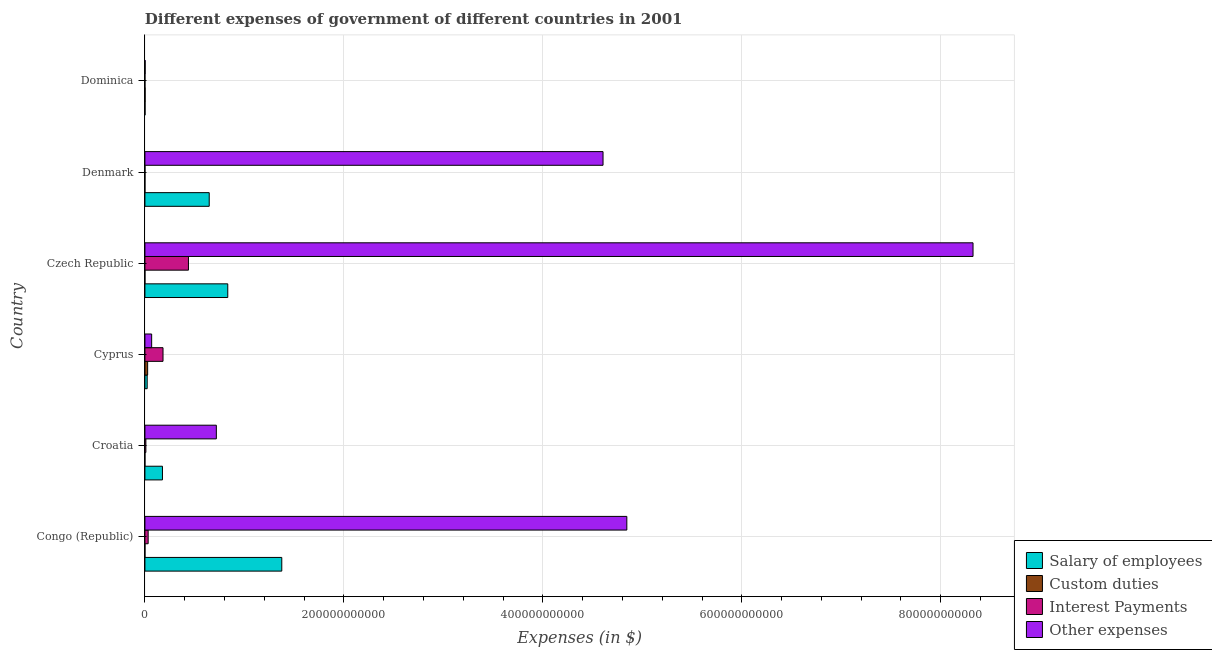How many different coloured bars are there?
Provide a short and direct response. 4. Are the number of bars per tick equal to the number of legend labels?
Your answer should be compact. No. How many bars are there on the 2nd tick from the top?
Ensure brevity in your answer.  4. How many bars are there on the 5th tick from the bottom?
Ensure brevity in your answer.  4. What is the label of the 2nd group of bars from the top?
Ensure brevity in your answer.  Denmark. In how many cases, is the number of bars for a given country not equal to the number of legend labels?
Your answer should be very brief. 1. What is the amount spent on custom duties in Dominica?
Provide a succinct answer. 2.00e+08. Across all countries, what is the maximum amount spent on salary of employees?
Your answer should be compact. 1.38e+11. Across all countries, what is the minimum amount spent on salary of employees?
Make the answer very short. 1.24e+08. In which country was the amount spent on salary of employees maximum?
Offer a terse response. Congo (Republic). What is the total amount spent on custom duties in the graph?
Offer a terse response. 2.97e+09. What is the difference between the amount spent on other expenses in Cyprus and that in Denmark?
Your answer should be very brief. -4.54e+11. What is the difference between the amount spent on salary of employees in Cyprus and the amount spent on other expenses in Congo (Republic)?
Make the answer very short. -4.82e+11. What is the average amount spent on custom duties per country?
Give a very brief answer. 4.94e+08. What is the difference between the amount spent on salary of employees and amount spent on custom duties in Cyprus?
Keep it short and to the point. -4.53e+08. What is the ratio of the amount spent on salary of employees in Cyprus to that in Denmark?
Make the answer very short. 0.04. Is the amount spent on interest payments in Congo (Republic) less than that in Czech Republic?
Give a very brief answer. Yes. Is the difference between the amount spent on interest payments in Denmark and Dominica greater than the difference between the amount spent on custom duties in Denmark and Dominica?
Provide a short and direct response. Yes. What is the difference between the highest and the second highest amount spent on salary of employees?
Offer a terse response. 5.43e+1. What is the difference between the highest and the lowest amount spent on other expenses?
Provide a short and direct response. 8.32e+11. Are all the bars in the graph horizontal?
Ensure brevity in your answer.  Yes. What is the difference between two consecutive major ticks on the X-axis?
Offer a terse response. 2.00e+11. Are the values on the major ticks of X-axis written in scientific E-notation?
Provide a succinct answer. No. Where does the legend appear in the graph?
Keep it short and to the point. Bottom right. How many legend labels are there?
Your response must be concise. 4. How are the legend labels stacked?
Give a very brief answer. Vertical. What is the title of the graph?
Your answer should be very brief. Different expenses of government of different countries in 2001. Does "Payroll services" appear as one of the legend labels in the graph?
Keep it short and to the point. No. What is the label or title of the X-axis?
Provide a succinct answer. Expenses (in $). What is the Expenses (in $) of Salary of employees in Congo (Republic)?
Your answer should be very brief. 1.38e+11. What is the Expenses (in $) in Custom duties in Congo (Republic)?
Your answer should be compact. 2.78e+07. What is the Expenses (in $) of Interest Payments in Congo (Republic)?
Your answer should be compact. 3.26e+09. What is the Expenses (in $) of Other expenses in Congo (Republic)?
Your response must be concise. 4.84e+11. What is the Expenses (in $) of Salary of employees in Croatia?
Your answer should be compact. 1.76e+1. What is the Expenses (in $) in Custom duties in Croatia?
Make the answer very short. 2.56e+06. What is the Expenses (in $) in Interest Payments in Croatia?
Provide a succinct answer. 9.60e+08. What is the Expenses (in $) of Other expenses in Croatia?
Provide a succinct answer. 7.18e+1. What is the Expenses (in $) in Salary of employees in Cyprus?
Ensure brevity in your answer.  2.28e+09. What is the Expenses (in $) of Custom duties in Cyprus?
Your answer should be compact. 2.73e+09. What is the Expenses (in $) of Interest Payments in Cyprus?
Provide a succinct answer. 1.82e+1. What is the Expenses (in $) of Other expenses in Cyprus?
Your response must be concise. 6.77e+09. What is the Expenses (in $) in Salary of employees in Czech Republic?
Keep it short and to the point. 8.33e+1. What is the Expenses (in $) in Custom duties in Czech Republic?
Give a very brief answer. 0. What is the Expenses (in $) of Interest Payments in Czech Republic?
Your answer should be very brief. 4.38e+1. What is the Expenses (in $) of Other expenses in Czech Republic?
Provide a succinct answer. 8.32e+11. What is the Expenses (in $) of Salary of employees in Denmark?
Ensure brevity in your answer.  6.46e+1. What is the Expenses (in $) of Interest Payments in Denmark?
Your answer should be very brief. 4.02e+07. What is the Expenses (in $) in Other expenses in Denmark?
Provide a succinct answer. 4.61e+11. What is the Expenses (in $) of Salary of employees in Dominica?
Your response must be concise. 1.24e+08. What is the Expenses (in $) in Custom duties in Dominica?
Offer a very short reply. 2.00e+08. What is the Expenses (in $) of Interest Payments in Dominica?
Your response must be concise. 2.60e+06. What is the Expenses (in $) of Other expenses in Dominica?
Give a very brief answer. 2.38e+08. Across all countries, what is the maximum Expenses (in $) of Salary of employees?
Your response must be concise. 1.38e+11. Across all countries, what is the maximum Expenses (in $) in Custom duties?
Give a very brief answer. 2.73e+09. Across all countries, what is the maximum Expenses (in $) of Interest Payments?
Ensure brevity in your answer.  4.38e+1. Across all countries, what is the maximum Expenses (in $) of Other expenses?
Make the answer very short. 8.32e+11. Across all countries, what is the minimum Expenses (in $) in Salary of employees?
Your response must be concise. 1.24e+08. Across all countries, what is the minimum Expenses (in $) in Interest Payments?
Ensure brevity in your answer.  2.60e+06. Across all countries, what is the minimum Expenses (in $) in Other expenses?
Give a very brief answer. 2.38e+08. What is the total Expenses (in $) of Salary of employees in the graph?
Give a very brief answer. 3.06e+11. What is the total Expenses (in $) of Custom duties in the graph?
Your response must be concise. 2.97e+09. What is the total Expenses (in $) of Interest Payments in the graph?
Your answer should be very brief. 6.62e+1. What is the total Expenses (in $) of Other expenses in the graph?
Offer a terse response. 1.86e+12. What is the difference between the Expenses (in $) in Salary of employees in Congo (Republic) and that in Croatia?
Your response must be concise. 1.20e+11. What is the difference between the Expenses (in $) of Custom duties in Congo (Republic) and that in Croatia?
Provide a short and direct response. 2.52e+07. What is the difference between the Expenses (in $) of Interest Payments in Congo (Republic) and that in Croatia?
Ensure brevity in your answer.  2.30e+09. What is the difference between the Expenses (in $) in Other expenses in Congo (Republic) and that in Croatia?
Offer a very short reply. 4.13e+11. What is the difference between the Expenses (in $) in Salary of employees in Congo (Republic) and that in Cyprus?
Offer a very short reply. 1.35e+11. What is the difference between the Expenses (in $) in Custom duties in Congo (Republic) and that in Cyprus?
Keep it short and to the point. -2.70e+09. What is the difference between the Expenses (in $) of Interest Payments in Congo (Republic) and that in Cyprus?
Keep it short and to the point. -1.49e+1. What is the difference between the Expenses (in $) in Other expenses in Congo (Republic) and that in Cyprus?
Provide a short and direct response. 4.78e+11. What is the difference between the Expenses (in $) of Salary of employees in Congo (Republic) and that in Czech Republic?
Make the answer very short. 5.43e+1. What is the difference between the Expenses (in $) in Interest Payments in Congo (Republic) and that in Czech Republic?
Provide a succinct answer. -4.05e+1. What is the difference between the Expenses (in $) in Other expenses in Congo (Republic) and that in Czech Republic?
Your answer should be very brief. -3.48e+11. What is the difference between the Expenses (in $) of Salary of employees in Congo (Republic) and that in Denmark?
Offer a very short reply. 7.29e+1. What is the difference between the Expenses (in $) of Custom duties in Congo (Republic) and that in Denmark?
Ensure brevity in your answer.  2.08e+07. What is the difference between the Expenses (in $) of Interest Payments in Congo (Republic) and that in Denmark?
Your response must be concise. 3.22e+09. What is the difference between the Expenses (in $) in Other expenses in Congo (Republic) and that in Denmark?
Your answer should be compact. 2.39e+1. What is the difference between the Expenses (in $) of Salary of employees in Congo (Republic) and that in Dominica?
Provide a succinct answer. 1.37e+11. What is the difference between the Expenses (in $) in Custom duties in Congo (Republic) and that in Dominica?
Provide a succinct answer. -1.72e+08. What is the difference between the Expenses (in $) of Interest Payments in Congo (Republic) and that in Dominica?
Keep it short and to the point. 3.26e+09. What is the difference between the Expenses (in $) in Other expenses in Congo (Republic) and that in Dominica?
Offer a terse response. 4.84e+11. What is the difference between the Expenses (in $) in Salary of employees in Croatia and that in Cyprus?
Ensure brevity in your answer.  1.54e+1. What is the difference between the Expenses (in $) of Custom duties in Croatia and that in Cyprus?
Offer a very short reply. -2.73e+09. What is the difference between the Expenses (in $) in Interest Payments in Croatia and that in Cyprus?
Keep it short and to the point. -1.72e+1. What is the difference between the Expenses (in $) of Other expenses in Croatia and that in Cyprus?
Your response must be concise. 6.50e+1. What is the difference between the Expenses (in $) in Salary of employees in Croatia and that in Czech Republic?
Provide a short and direct response. -6.56e+1. What is the difference between the Expenses (in $) in Interest Payments in Croatia and that in Czech Republic?
Ensure brevity in your answer.  -4.28e+1. What is the difference between the Expenses (in $) of Other expenses in Croatia and that in Czech Republic?
Give a very brief answer. -7.61e+11. What is the difference between the Expenses (in $) of Salary of employees in Croatia and that in Denmark?
Your answer should be very brief. -4.70e+1. What is the difference between the Expenses (in $) in Custom duties in Croatia and that in Denmark?
Make the answer very short. -4.44e+06. What is the difference between the Expenses (in $) in Interest Payments in Croatia and that in Denmark?
Provide a short and direct response. 9.20e+08. What is the difference between the Expenses (in $) in Other expenses in Croatia and that in Denmark?
Your answer should be very brief. -3.89e+11. What is the difference between the Expenses (in $) in Salary of employees in Croatia and that in Dominica?
Ensure brevity in your answer.  1.75e+1. What is the difference between the Expenses (in $) in Custom duties in Croatia and that in Dominica?
Offer a very short reply. -1.97e+08. What is the difference between the Expenses (in $) of Interest Payments in Croatia and that in Dominica?
Provide a succinct answer. 9.57e+08. What is the difference between the Expenses (in $) of Other expenses in Croatia and that in Dominica?
Your answer should be compact. 7.16e+1. What is the difference between the Expenses (in $) of Salary of employees in Cyprus and that in Czech Republic?
Provide a succinct answer. -8.10e+1. What is the difference between the Expenses (in $) of Interest Payments in Cyprus and that in Czech Republic?
Your answer should be very brief. -2.56e+1. What is the difference between the Expenses (in $) of Other expenses in Cyprus and that in Czech Republic?
Keep it short and to the point. -8.26e+11. What is the difference between the Expenses (in $) of Salary of employees in Cyprus and that in Denmark?
Offer a very short reply. -6.24e+1. What is the difference between the Expenses (in $) in Custom duties in Cyprus and that in Denmark?
Your response must be concise. 2.72e+09. What is the difference between the Expenses (in $) in Interest Payments in Cyprus and that in Denmark?
Keep it short and to the point. 1.82e+1. What is the difference between the Expenses (in $) of Other expenses in Cyprus and that in Denmark?
Ensure brevity in your answer.  -4.54e+11. What is the difference between the Expenses (in $) of Salary of employees in Cyprus and that in Dominica?
Offer a very short reply. 2.15e+09. What is the difference between the Expenses (in $) of Custom duties in Cyprus and that in Dominica?
Make the answer very short. 2.53e+09. What is the difference between the Expenses (in $) of Interest Payments in Cyprus and that in Dominica?
Provide a short and direct response. 1.82e+1. What is the difference between the Expenses (in $) in Other expenses in Cyprus and that in Dominica?
Offer a terse response. 6.53e+09. What is the difference between the Expenses (in $) of Salary of employees in Czech Republic and that in Denmark?
Your answer should be compact. 1.86e+1. What is the difference between the Expenses (in $) in Interest Payments in Czech Republic and that in Denmark?
Your response must be concise. 4.37e+1. What is the difference between the Expenses (in $) in Other expenses in Czech Republic and that in Denmark?
Offer a terse response. 3.72e+11. What is the difference between the Expenses (in $) in Salary of employees in Czech Republic and that in Dominica?
Give a very brief answer. 8.31e+1. What is the difference between the Expenses (in $) in Interest Payments in Czech Republic and that in Dominica?
Your answer should be compact. 4.38e+1. What is the difference between the Expenses (in $) in Other expenses in Czech Republic and that in Dominica?
Make the answer very short. 8.32e+11. What is the difference between the Expenses (in $) of Salary of employees in Denmark and that in Dominica?
Make the answer very short. 6.45e+1. What is the difference between the Expenses (in $) of Custom duties in Denmark and that in Dominica?
Provide a succinct answer. -1.92e+08. What is the difference between the Expenses (in $) of Interest Payments in Denmark and that in Dominica?
Your answer should be compact. 3.76e+07. What is the difference between the Expenses (in $) of Other expenses in Denmark and that in Dominica?
Offer a very short reply. 4.60e+11. What is the difference between the Expenses (in $) in Salary of employees in Congo (Republic) and the Expenses (in $) in Custom duties in Croatia?
Ensure brevity in your answer.  1.38e+11. What is the difference between the Expenses (in $) of Salary of employees in Congo (Republic) and the Expenses (in $) of Interest Payments in Croatia?
Provide a short and direct response. 1.37e+11. What is the difference between the Expenses (in $) in Salary of employees in Congo (Republic) and the Expenses (in $) in Other expenses in Croatia?
Your response must be concise. 6.58e+1. What is the difference between the Expenses (in $) of Custom duties in Congo (Republic) and the Expenses (in $) of Interest Payments in Croatia?
Provide a short and direct response. -9.32e+08. What is the difference between the Expenses (in $) in Custom duties in Congo (Republic) and the Expenses (in $) in Other expenses in Croatia?
Your answer should be very brief. -7.18e+1. What is the difference between the Expenses (in $) in Interest Payments in Congo (Republic) and the Expenses (in $) in Other expenses in Croatia?
Your response must be concise. -6.85e+1. What is the difference between the Expenses (in $) in Salary of employees in Congo (Republic) and the Expenses (in $) in Custom duties in Cyprus?
Offer a terse response. 1.35e+11. What is the difference between the Expenses (in $) of Salary of employees in Congo (Republic) and the Expenses (in $) of Interest Payments in Cyprus?
Your answer should be very brief. 1.19e+11. What is the difference between the Expenses (in $) in Salary of employees in Congo (Republic) and the Expenses (in $) in Other expenses in Cyprus?
Your response must be concise. 1.31e+11. What is the difference between the Expenses (in $) in Custom duties in Congo (Republic) and the Expenses (in $) in Interest Payments in Cyprus?
Give a very brief answer. -1.82e+1. What is the difference between the Expenses (in $) of Custom duties in Congo (Republic) and the Expenses (in $) of Other expenses in Cyprus?
Give a very brief answer. -6.74e+09. What is the difference between the Expenses (in $) in Interest Payments in Congo (Republic) and the Expenses (in $) in Other expenses in Cyprus?
Offer a very short reply. -3.51e+09. What is the difference between the Expenses (in $) in Salary of employees in Congo (Republic) and the Expenses (in $) in Interest Payments in Czech Republic?
Your response must be concise. 9.38e+1. What is the difference between the Expenses (in $) of Salary of employees in Congo (Republic) and the Expenses (in $) of Other expenses in Czech Republic?
Make the answer very short. -6.95e+11. What is the difference between the Expenses (in $) of Custom duties in Congo (Republic) and the Expenses (in $) of Interest Payments in Czech Republic?
Offer a terse response. -4.37e+1. What is the difference between the Expenses (in $) of Custom duties in Congo (Republic) and the Expenses (in $) of Other expenses in Czech Republic?
Ensure brevity in your answer.  -8.32e+11. What is the difference between the Expenses (in $) of Interest Payments in Congo (Republic) and the Expenses (in $) of Other expenses in Czech Republic?
Keep it short and to the point. -8.29e+11. What is the difference between the Expenses (in $) of Salary of employees in Congo (Republic) and the Expenses (in $) of Custom duties in Denmark?
Offer a very short reply. 1.38e+11. What is the difference between the Expenses (in $) of Salary of employees in Congo (Republic) and the Expenses (in $) of Interest Payments in Denmark?
Your answer should be very brief. 1.38e+11. What is the difference between the Expenses (in $) in Salary of employees in Congo (Republic) and the Expenses (in $) in Other expenses in Denmark?
Make the answer very short. -3.23e+11. What is the difference between the Expenses (in $) of Custom duties in Congo (Republic) and the Expenses (in $) of Interest Payments in Denmark?
Offer a very short reply. -1.24e+07. What is the difference between the Expenses (in $) of Custom duties in Congo (Republic) and the Expenses (in $) of Other expenses in Denmark?
Keep it short and to the point. -4.60e+11. What is the difference between the Expenses (in $) of Interest Payments in Congo (Republic) and the Expenses (in $) of Other expenses in Denmark?
Offer a terse response. -4.57e+11. What is the difference between the Expenses (in $) in Salary of employees in Congo (Republic) and the Expenses (in $) in Custom duties in Dominica?
Ensure brevity in your answer.  1.37e+11. What is the difference between the Expenses (in $) in Salary of employees in Congo (Republic) and the Expenses (in $) in Interest Payments in Dominica?
Provide a short and direct response. 1.38e+11. What is the difference between the Expenses (in $) in Salary of employees in Congo (Republic) and the Expenses (in $) in Other expenses in Dominica?
Ensure brevity in your answer.  1.37e+11. What is the difference between the Expenses (in $) in Custom duties in Congo (Republic) and the Expenses (in $) in Interest Payments in Dominica?
Provide a succinct answer. 2.52e+07. What is the difference between the Expenses (in $) of Custom duties in Congo (Republic) and the Expenses (in $) of Other expenses in Dominica?
Offer a terse response. -2.10e+08. What is the difference between the Expenses (in $) in Interest Payments in Congo (Republic) and the Expenses (in $) in Other expenses in Dominica?
Your answer should be very brief. 3.02e+09. What is the difference between the Expenses (in $) in Salary of employees in Croatia and the Expenses (in $) in Custom duties in Cyprus?
Give a very brief answer. 1.49e+1. What is the difference between the Expenses (in $) in Salary of employees in Croatia and the Expenses (in $) in Interest Payments in Cyprus?
Your answer should be compact. -5.65e+08. What is the difference between the Expenses (in $) in Salary of employees in Croatia and the Expenses (in $) in Other expenses in Cyprus?
Ensure brevity in your answer.  1.09e+1. What is the difference between the Expenses (in $) of Custom duties in Croatia and the Expenses (in $) of Interest Payments in Cyprus?
Your answer should be compact. -1.82e+1. What is the difference between the Expenses (in $) in Custom duties in Croatia and the Expenses (in $) in Other expenses in Cyprus?
Ensure brevity in your answer.  -6.77e+09. What is the difference between the Expenses (in $) in Interest Payments in Croatia and the Expenses (in $) in Other expenses in Cyprus?
Make the answer very short. -5.81e+09. What is the difference between the Expenses (in $) of Salary of employees in Croatia and the Expenses (in $) of Interest Payments in Czech Republic?
Give a very brief answer. -2.61e+1. What is the difference between the Expenses (in $) in Salary of employees in Croatia and the Expenses (in $) in Other expenses in Czech Republic?
Offer a terse response. -8.15e+11. What is the difference between the Expenses (in $) of Custom duties in Croatia and the Expenses (in $) of Interest Payments in Czech Republic?
Your answer should be very brief. -4.38e+1. What is the difference between the Expenses (in $) of Custom duties in Croatia and the Expenses (in $) of Other expenses in Czech Republic?
Your response must be concise. -8.32e+11. What is the difference between the Expenses (in $) in Interest Payments in Croatia and the Expenses (in $) in Other expenses in Czech Republic?
Your response must be concise. -8.31e+11. What is the difference between the Expenses (in $) of Salary of employees in Croatia and the Expenses (in $) of Custom duties in Denmark?
Provide a succinct answer. 1.76e+1. What is the difference between the Expenses (in $) of Salary of employees in Croatia and the Expenses (in $) of Interest Payments in Denmark?
Your response must be concise. 1.76e+1. What is the difference between the Expenses (in $) in Salary of employees in Croatia and the Expenses (in $) in Other expenses in Denmark?
Offer a very short reply. -4.43e+11. What is the difference between the Expenses (in $) in Custom duties in Croatia and the Expenses (in $) in Interest Payments in Denmark?
Provide a succinct answer. -3.76e+07. What is the difference between the Expenses (in $) of Custom duties in Croatia and the Expenses (in $) of Other expenses in Denmark?
Give a very brief answer. -4.61e+11. What is the difference between the Expenses (in $) of Interest Payments in Croatia and the Expenses (in $) of Other expenses in Denmark?
Give a very brief answer. -4.60e+11. What is the difference between the Expenses (in $) of Salary of employees in Croatia and the Expenses (in $) of Custom duties in Dominica?
Provide a short and direct response. 1.74e+1. What is the difference between the Expenses (in $) in Salary of employees in Croatia and the Expenses (in $) in Interest Payments in Dominica?
Provide a short and direct response. 1.76e+1. What is the difference between the Expenses (in $) of Salary of employees in Croatia and the Expenses (in $) of Other expenses in Dominica?
Make the answer very short. 1.74e+1. What is the difference between the Expenses (in $) in Custom duties in Croatia and the Expenses (in $) in Interest Payments in Dominica?
Offer a terse response. -4.00e+04. What is the difference between the Expenses (in $) in Custom duties in Croatia and the Expenses (in $) in Other expenses in Dominica?
Make the answer very short. -2.36e+08. What is the difference between the Expenses (in $) of Interest Payments in Croatia and the Expenses (in $) of Other expenses in Dominica?
Your answer should be compact. 7.22e+08. What is the difference between the Expenses (in $) of Salary of employees in Cyprus and the Expenses (in $) of Interest Payments in Czech Republic?
Give a very brief answer. -4.15e+1. What is the difference between the Expenses (in $) of Salary of employees in Cyprus and the Expenses (in $) of Other expenses in Czech Republic?
Your answer should be compact. -8.30e+11. What is the difference between the Expenses (in $) of Custom duties in Cyprus and the Expenses (in $) of Interest Payments in Czech Republic?
Your answer should be very brief. -4.10e+1. What is the difference between the Expenses (in $) of Custom duties in Cyprus and the Expenses (in $) of Other expenses in Czech Republic?
Offer a terse response. -8.30e+11. What is the difference between the Expenses (in $) in Interest Payments in Cyprus and the Expenses (in $) in Other expenses in Czech Republic?
Make the answer very short. -8.14e+11. What is the difference between the Expenses (in $) of Salary of employees in Cyprus and the Expenses (in $) of Custom duties in Denmark?
Ensure brevity in your answer.  2.27e+09. What is the difference between the Expenses (in $) in Salary of employees in Cyprus and the Expenses (in $) in Interest Payments in Denmark?
Make the answer very short. 2.23e+09. What is the difference between the Expenses (in $) in Salary of employees in Cyprus and the Expenses (in $) in Other expenses in Denmark?
Your answer should be very brief. -4.58e+11. What is the difference between the Expenses (in $) of Custom duties in Cyprus and the Expenses (in $) of Interest Payments in Denmark?
Your answer should be compact. 2.69e+09. What is the difference between the Expenses (in $) of Custom duties in Cyprus and the Expenses (in $) of Other expenses in Denmark?
Your answer should be compact. -4.58e+11. What is the difference between the Expenses (in $) of Interest Payments in Cyprus and the Expenses (in $) of Other expenses in Denmark?
Your response must be concise. -4.42e+11. What is the difference between the Expenses (in $) of Salary of employees in Cyprus and the Expenses (in $) of Custom duties in Dominica?
Provide a short and direct response. 2.08e+09. What is the difference between the Expenses (in $) of Salary of employees in Cyprus and the Expenses (in $) of Interest Payments in Dominica?
Your answer should be very brief. 2.27e+09. What is the difference between the Expenses (in $) in Salary of employees in Cyprus and the Expenses (in $) in Other expenses in Dominica?
Your response must be concise. 2.04e+09. What is the difference between the Expenses (in $) in Custom duties in Cyprus and the Expenses (in $) in Interest Payments in Dominica?
Keep it short and to the point. 2.73e+09. What is the difference between the Expenses (in $) of Custom duties in Cyprus and the Expenses (in $) of Other expenses in Dominica?
Your answer should be very brief. 2.49e+09. What is the difference between the Expenses (in $) in Interest Payments in Cyprus and the Expenses (in $) in Other expenses in Dominica?
Offer a very short reply. 1.80e+1. What is the difference between the Expenses (in $) in Salary of employees in Czech Republic and the Expenses (in $) in Custom duties in Denmark?
Make the answer very short. 8.33e+1. What is the difference between the Expenses (in $) in Salary of employees in Czech Republic and the Expenses (in $) in Interest Payments in Denmark?
Make the answer very short. 8.32e+1. What is the difference between the Expenses (in $) of Salary of employees in Czech Republic and the Expenses (in $) of Other expenses in Denmark?
Offer a terse response. -3.77e+11. What is the difference between the Expenses (in $) in Interest Payments in Czech Republic and the Expenses (in $) in Other expenses in Denmark?
Your answer should be compact. -4.17e+11. What is the difference between the Expenses (in $) of Salary of employees in Czech Republic and the Expenses (in $) of Custom duties in Dominica?
Provide a short and direct response. 8.31e+1. What is the difference between the Expenses (in $) in Salary of employees in Czech Republic and the Expenses (in $) in Interest Payments in Dominica?
Your response must be concise. 8.33e+1. What is the difference between the Expenses (in $) of Salary of employees in Czech Republic and the Expenses (in $) of Other expenses in Dominica?
Provide a short and direct response. 8.30e+1. What is the difference between the Expenses (in $) of Interest Payments in Czech Republic and the Expenses (in $) of Other expenses in Dominica?
Provide a short and direct response. 4.35e+1. What is the difference between the Expenses (in $) in Salary of employees in Denmark and the Expenses (in $) in Custom duties in Dominica?
Offer a very short reply. 6.44e+1. What is the difference between the Expenses (in $) of Salary of employees in Denmark and the Expenses (in $) of Interest Payments in Dominica?
Provide a succinct answer. 6.46e+1. What is the difference between the Expenses (in $) in Salary of employees in Denmark and the Expenses (in $) in Other expenses in Dominica?
Provide a succinct answer. 6.44e+1. What is the difference between the Expenses (in $) of Custom duties in Denmark and the Expenses (in $) of Interest Payments in Dominica?
Your answer should be very brief. 4.40e+06. What is the difference between the Expenses (in $) in Custom duties in Denmark and the Expenses (in $) in Other expenses in Dominica?
Offer a terse response. -2.31e+08. What is the difference between the Expenses (in $) in Interest Payments in Denmark and the Expenses (in $) in Other expenses in Dominica?
Keep it short and to the point. -1.98e+08. What is the average Expenses (in $) in Salary of employees per country?
Your response must be concise. 5.09e+1. What is the average Expenses (in $) of Custom duties per country?
Ensure brevity in your answer.  4.94e+08. What is the average Expenses (in $) of Interest Payments per country?
Provide a short and direct response. 1.10e+1. What is the average Expenses (in $) of Other expenses per country?
Your answer should be compact. 3.09e+11. What is the difference between the Expenses (in $) of Salary of employees and Expenses (in $) of Custom duties in Congo (Republic)?
Ensure brevity in your answer.  1.38e+11. What is the difference between the Expenses (in $) in Salary of employees and Expenses (in $) in Interest Payments in Congo (Republic)?
Provide a succinct answer. 1.34e+11. What is the difference between the Expenses (in $) in Salary of employees and Expenses (in $) in Other expenses in Congo (Republic)?
Make the answer very short. -3.47e+11. What is the difference between the Expenses (in $) of Custom duties and Expenses (in $) of Interest Payments in Congo (Republic)?
Offer a terse response. -3.23e+09. What is the difference between the Expenses (in $) of Custom duties and Expenses (in $) of Other expenses in Congo (Republic)?
Your answer should be very brief. -4.84e+11. What is the difference between the Expenses (in $) of Interest Payments and Expenses (in $) of Other expenses in Congo (Republic)?
Make the answer very short. -4.81e+11. What is the difference between the Expenses (in $) in Salary of employees and Expenses (in $) in Custom duties in Croatia?
Your answer should be compact. 1.76e+1. What is the difference between the Expenses (in $) in Salary of employees and Expenses (in $) in Interest Payments in Croatia?
Ensure brevity in your answer.  1.67e+1. What is the difference between the Expenses (in $) in Salary of employees and Expenses (in $) in Other expenses in Croatia?
Make the answer very short. -5.42e+1. What is the difference between the Expenses (in $) in Custom duties and Expenses (in $) in Interest Payments in Croatia?
Offer a very short reply. -9.58e+08. What is the difference between the Expenses (in $) in Custom duties and Expenses (in $) in Other expenses in Croatia?
Your answer should be very brief. -7.18e+1. What is the difference between the Expenses (in $) of Interest Payments and Expenses (in $) of Other expenses in Croatia?
Make the answer very short. -7.08e+1. What is the difference between the Expenses (in $) in Salary of employees and Expenses (in $) in Custom duties in Cyprus?
Keep it short and to the point. -4.53e+08. What is the difference between the Expenses (in $) of Salary of employees and Expenses (in $) of Interest Payments in Cyprus?
Your response must be concise. -1.59e+1. What is the difference between the Expenses (in $) in Salary of employees and Expenses (in $) in Other expenses in Cyprus?
Offer a very short reply. -4.49e+09. What is the difference between the Expenses (in $) of Custom duties and Expenses (in $) of Interest Payments in Cyprus?
Your answer should be compact. -1.55e+1. What is the difference between the Expenses (in $) of Custom duties and Expenses (in $) of Other expenses in Cyprus?
Offer a terse response. -4.04e+09. What is the difference between the Expenses (in $) of Interest Payments and Expenses (in $) of Other expenses in Cyprus?
Give a very brief answer. 1.14e+1. What is the difference between the Expenses (in $) in Salary of employees and Expenses (in $) in Interest Payments in Czech Republic?
Your answer should be compact. 3.95e+1. What is the difference between the Expenses (in $) in Salary of employees and Expenses (in $) in Other expenses in Czech Republic?
Offer a terse response. -7.49e+11. What is the difference between the Expenses (in $) of Interest Payments and Expenses (in $) of Other expenses in Czech Republic?
Keep it short and to the point. -7.89e+11. What is the difference between the Expenses (in $) of Salary of employees and Expenses (in $) of Custom duties in Denmark?
Your answer should be very brief. 6.46e+1. What is the difference between the Expenses (in $) in Salary of employees and Expenses (in $) in Interest Payments in Denmark?
Provide a succinct answer. 6.46e+1. What is the difference between the Expenses (in $) of Salary of employees and Expenses (in $) of Other expenses in Denmark?
Your response must be concise. -3.96e+11. What is the difference between the Expenses (in $) in Custom duties and Expenses (in $) in Interest Payments in Denmark?
Provide a succinct answer. -3.32e+07. What is the difference between the Expenses (in $) in Custom duties and Expenses (in $) in Other expenses in Denmark?
Offer a very short reply. -4.61e+11. What is the difference between the Expenses (in $) of Interest Payments and Expenses (in $) of Other expenses in Denmark?
Make the answer very short. -4.60e+11. What is the difference between the Expenses (in $) in Salary of employees and Expenses (in $) in Custom duties in Dominica?
Your answer should be compact. -7.58e+07. What is the difference between the Expenses (in $) of Salary of employees and Expenses (in $) of Interest Payments in Dominica?
Offer a very short reply. 1.21e+08. What is the difference between the Expenses (in $) in Salary of employees and Expenses (in $) in Other expenses in Dominica?
Your answer should be very brief. -1.14e+08. What is the difference between the Expenses (in $) of Custom duties and Expenses (in $) of Interest Payments in Dominica?
Provide a succinct answer. 1.97e+08. What is the difference between the Expenses (in $) of Custom duties and Expenses (in $) of Other expenses in Dominica?
Your answer should be very brief. -3.87e+07. What is the difference between the Expenses (in $) in Interest Payments and Expenses (in $) in Other expenses in Dominica?
Your response must be concise. -2.36e+08. What is the ratio of the Expenses (in $) in Salary of employees in Congo (Republic) to that in Croatia?
Offer a terse response. 7.8. What is the ratio of the Expenses (in $) of Custom duties in Congo (Republic) to that in Croatia?
Your response must be concise. 10.86. What is the ratio of the Expenses (in $) of Interest Payments in Congo (Republic) to that in Croatia?
Your response must be concise. 3.4. What is the ratio of the Expenses (in $) of Other expenses in Congo (Republic) to that in Croatia?
Provide a succinct answer. 6.75. What is the ratio of the Expenses (in $) of Salary of employees in Congo (Republic) to that in Cyprus?
Your answer should be compact. 60.47. What is the ratio of the Expenses (in $) of Custom duties in Congo (Republic) to that in Cyprus?
Provide a short and direct response. 0.01. What is the ratio of the Expenses (in $) of Interest Payments in Congo (Republic) to that in Cyprus?
Provide a succinct answer. 0.18. What is the ratio of the Expenses (in $) in Other expenses in Congo (Republic) to that in Cyprus?
Make the answer very short. 71.56. What is the ratio of the Expenses (in $) of Salary of employees in Congo (Republic) to that in Czech Republic?
Your response must be concise. 1.65. What is the ratio of the Expenses (in $) in Interest Payments in Congo (Republic) to that in Czech Republic?
Your response must be concise. 0.07. What is the ratio of the Expenses (in $) of Other expenses in Congo (Republic) to that in Czech Republic?
Your answer should be compact. 0.58. What is the ratio of the Expenses (in $) in Salary of employees in Congo (Republic) to that in Denmark?
Provide a short and direct response. 2.13. What is the ratio of the Expenses (in $) in Custom duties in Congo (Republic) to that in Denmark?
Give a very brief answer. 3.97. What is the ratio of the Expenses (in $) in Interest Payments in Congo (Republic) to that in Denmark?
Provide a succinct answer. 81.09. What is the ratio of the Expenses (in $) of Other expenses in Congo (Republic) to that in Denmark?
Offer a terse response. 1.05. What is the ratio of the Expenses (in $) in Salary of employees in Congo (Republic) to that in Dominica?
Ensure brevity in your answer.  1112.12. What is the ratio of the Expenses (in $) in Custom duties in Congo (Republic) to that in Dominica?
Provide a succinct answer. 0.14. What is the ratio of the Expenses (in $) in Interest Payments in Congo (Republic) to that in Dominica?
Your answer should be compact. 1253.85. What is the ratio of the Expenses (in $) in Other expenses in Congo (Republic) to that in Dominica?
Provide a short and direct response. 2033.68. What is the ratio of the Expenses (in $) of Salary of employees in Croatia to that in Cyprus?
Provide a succinct answer. 7.75. What is the ratio of the Expenses (in $) of Custom duties in Croatia to that in Cyprus?
Your response must be concise. 0. What is the ratio of the Expenses (in $) of Interest Payments in Croatia to that in Cyprus?
Offer a very short reply. 0.05. What is the ratio of the Expenses (in $) in Other expenses in Croatia to that in Cyprus?
Provide a succinct answer. 10.61. What is the ratio of the Expenses (in $) in Salary of employees in Croatia to that in Czech Republic?
Provide a succinct answer. 0.21. What is the ratio of the Expenses (in $) in Interest Payments in Croatia to that in Czech Republic?
Make the answer very short. 0.02. What is the ratio of the Expenses (in $) of Other expenses in Croatia to that in Czech Republic?
Offer a very short reply. 0.09. What is the ratio of the Expenses (in $) of Salary of employees in Croatia to that in Denmark?
Offer a terse response. 0.27. What is the ratio of the Expenses (in $) in Custom duties in Croatia to that in Denmark?
Your response must be concise. 0.37. What is the ratio of the Expenses (in $) of Interest Payments in Croatia to that in Denmark?
Offer a terse response. 23.88. What is the ratio of the Expenses (in $) of Other expenses in Croatia to that in Denmark?
Make the answer very short. 0.16. What is the ratio of the Expenses (in $) in Salary of employees in Croatia to that in Dominica?
Ensure brevity in your answer.  142.52. What is the ratio of the Expenses (in $) in Custom duties in Croatia to that in Dominica?
Offer a very short reply. 0.01. What is the ratio of the Expenses (in $) in Interest Payments in Croatia to that in Dominica?
Give a very brief answer. 369.26. What is the ratio of the Expenses (in $) in Other expenses in Croatia to that in Dominica?
Keep it short and to the point. 301.43. What is the ratio of the Expenses (in $) of Salary of employees in Cyprus to that in Czech Republic?
Provide a succinct answer. 0.03. What is the ratio of the Expenses (in $) in Interest Payments in Cyprus to that in Czech Republic?
Your response must be concise. 0.42. What is the ratio of the Expenses (in $) of Other expenses in Cyprus to that in Czech Republic?
Make the answer very short. 0.01. What is the ratio of the Expenses (in $) in Salary of employees in Cyprus to that in Denmark?
Provide a succinct answer. 0.04. What is the ratio of the Expenses (in $) in Custom duties in Cyprus to that in Denmark?
Offer a very short reply. 389.8. What is the ratio of the Expenses (in $) in Interest Payments in Cyprus to that in Denmark?
Your answer should be compact. 452.61. What is the ratio of the Expenses (in $) in Other expenses in Cyprus to that in Denmark?
Give a very brief answer. 0.01. What is the ratio of the Expenses (in $) of Salary of employees in Cyprus to that in Dominica?
Ensure brevity in your answer.  18.39. What is the ratio of the Expenses (in $) of Custom duties in Cyprus to that in Dominica?
Provide a succinct answer. 13.68. What is the ratio of the Expenses (in $) in Interest Payments in Cyprus to that in Dominica?
Your answer should be compact. 6998.08. What is the ratio of the Expenses (in $) of Other expenses in Cyprus to that in Dominica?
Give a very brief answer. 28.42. What is the ratio of the Expenses (in $) of Salary of employees in Czech Republic to that in Denmark?
Your response must be concise. 1.29. What is the ratio of the Expenses (in $) in Interest Payments in Czech Republic to that in Denmark?
Give a very brief answer. 1088.46. What is the ratio of the Expenses (in $) of Other expenses in Czech Republic to that in Denmark?
Your answer should be very brief. 1.81. What is the ratio of the Expenses (in $) of Salary of employees in Czech Republic to that in Dominica?
Ensure brevity in your answer.  673.19. What is the ratio of the Expenses (in $) in Interest Payments in Czech Republic to that in Dominica?
Provide a short and direct response. 1.68e+04. What is the ratio of the Expenses (in $) of Other expenses in Czech Republic to that in Dominica?
Ensure brevity in your answer.  3494.66. What is the ratio of the Expenses (in $) in Salary of employees in Denmark to that in Dominica?
Offer a very short reply. 522.55. What is the ratio of the Expenses (in $) of Custom duties in Denmark to that in Dominica?
Make the answer very short. 0.04. What is the ratio of the Expenses (in $) of Interest Payments in Denmark to that in Dominica?
Your answer should be very brief. 15.46. What is the ratio of the Expenses (in $) of Other expenses in Denmark to that in Dominica?
Ensure brevity in your answer.  1933.29. What is the difference between the highest and the second highest Expenses (in $) in Salary of employees?
Provide a short and direct response. 5.43e+1. What is the difference between the highest and the second highest Expenses (in $) of Custom duties?
Your answer should be very brief. 2.53e+09. What is the difference between the highest and the second highest Expenses (in $) in Interest Payments?
Keep it short and to the point. 2.56e+1. What is the difference between the highest and the second highest Expenses (in $) of Other expenses?
Give a very brief answer. 3.48e+11. What is the difference between the highest and the lowest Expenses (in $) of Salary of employees?
Keep it short and to the point. 1.37e+11. What is the difference between the highest and the lowest Expenses (in $) in Custom duties?
Ensure brevity in your answer.  2.73e+09. What is the difference between the highest and the lowest Expenses (in $) of Interest Payments?
Give a very brief answer. 4.38e+1. What is the difference between the highest and the lowest Expenses (in $) in Other expenses?
Your answer should be compact. 8.32e+11. 